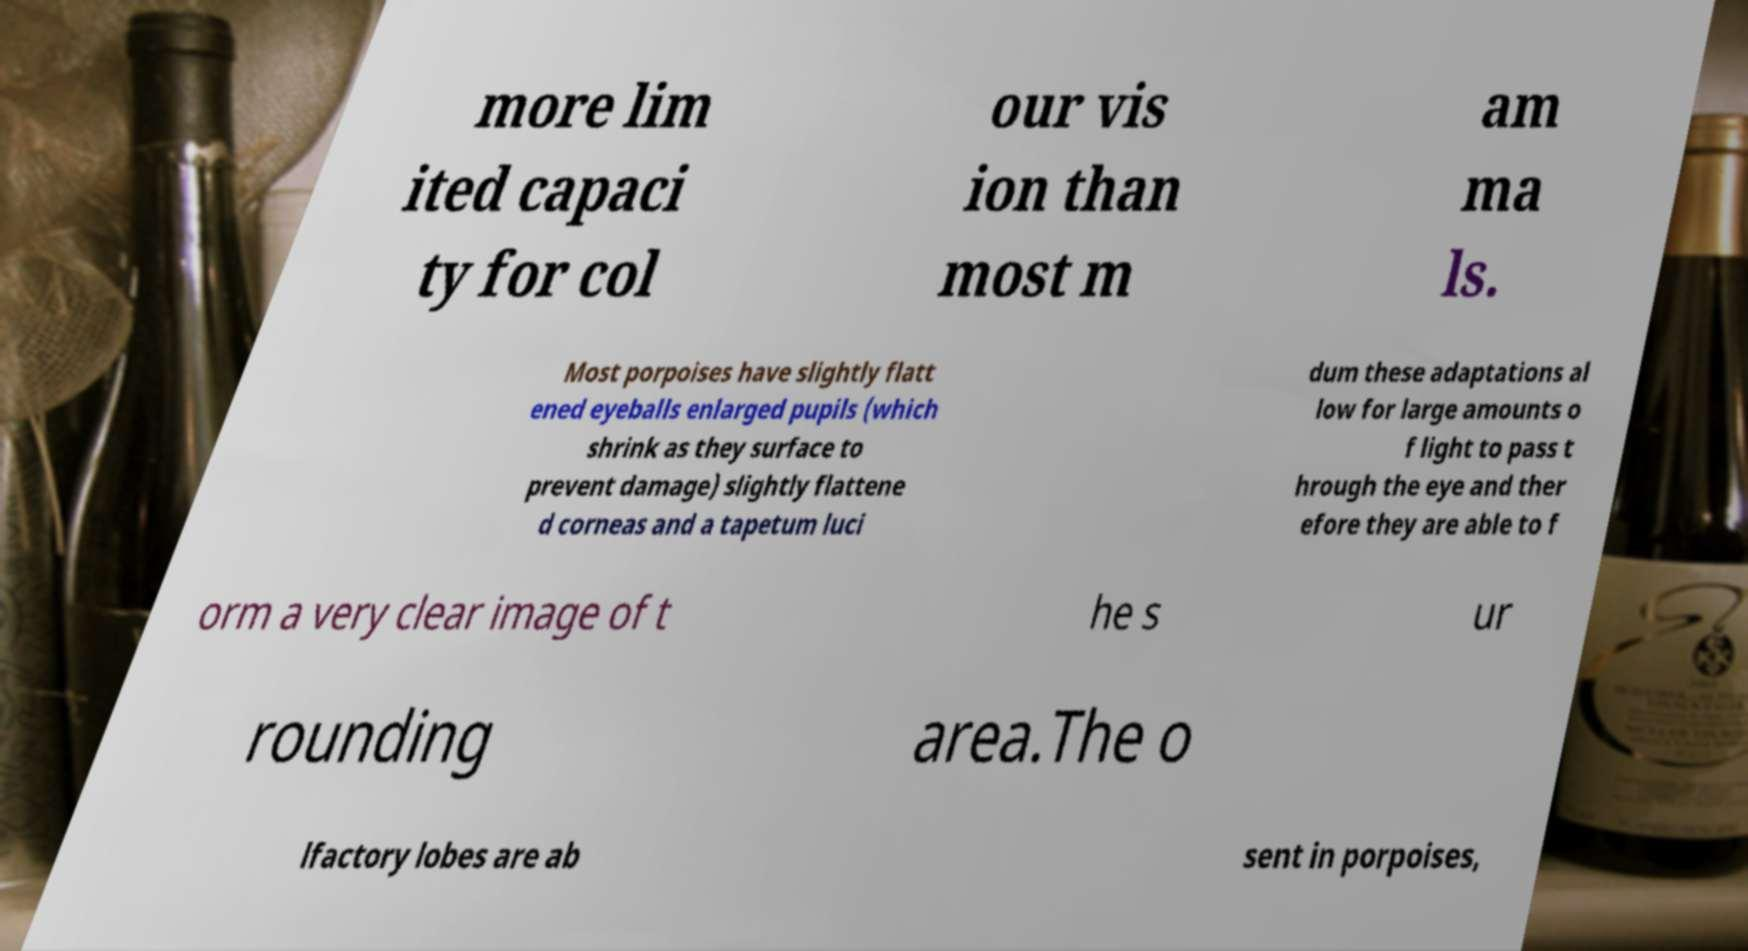I need the written content from this picture converted into text. Can you do that? more lim ited capaci ty for col our vis ion than most m am ma ls. Most porpoises have slightly flatt ened eyeballs enlarged pupils (which shrink as they surface to prevent damage) slightly flattene d corneas and a tapetum luci dum these adaptations al low for large amounts o f light to pass t hrough the eye and ther efore they are able to f orm a very clear image of t he s ur rounding area.The o lfactory lobes are ab sent in porpoises, 